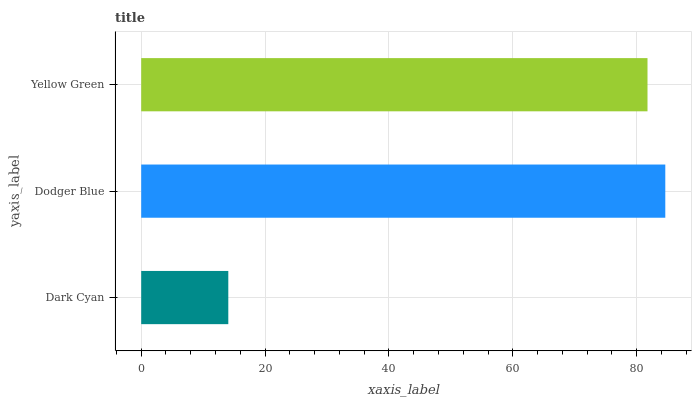Is Dark Cyan the minimum?
Answer yes or no. Yes. Is Dodger Blue the maximum?
Answer yes or no. Yes. Is Yellow Green the minimum?
Answer yes or no. No. Is Yellow Green the maximum?
Answer yes or no. No. Is Dodger Blue greater than Yellow Green?
Answer yes or no. Yes. Is Yellow Green less than Dodger Blue?
Answer yes or no. Yes. Is Yellow Green greater than Dodger Blue?
Answer yes or no. No. Is Dodger Blue less than Yellow Green?
Answer yes or no. No. Is Yellow Green the high median?
Answer yes or no. Yes. Is Yellow Green the low median?
Answer yes or no. Yes. Is Dodger Blue the high median?
Answer yes or no. No. Is Dodger Blue the low median?
Answer yes or no. No. 